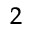Convert formula to latex. <formula><loc_0><loc_0><loc_500><loc_500>^ { 2 }</formula> 